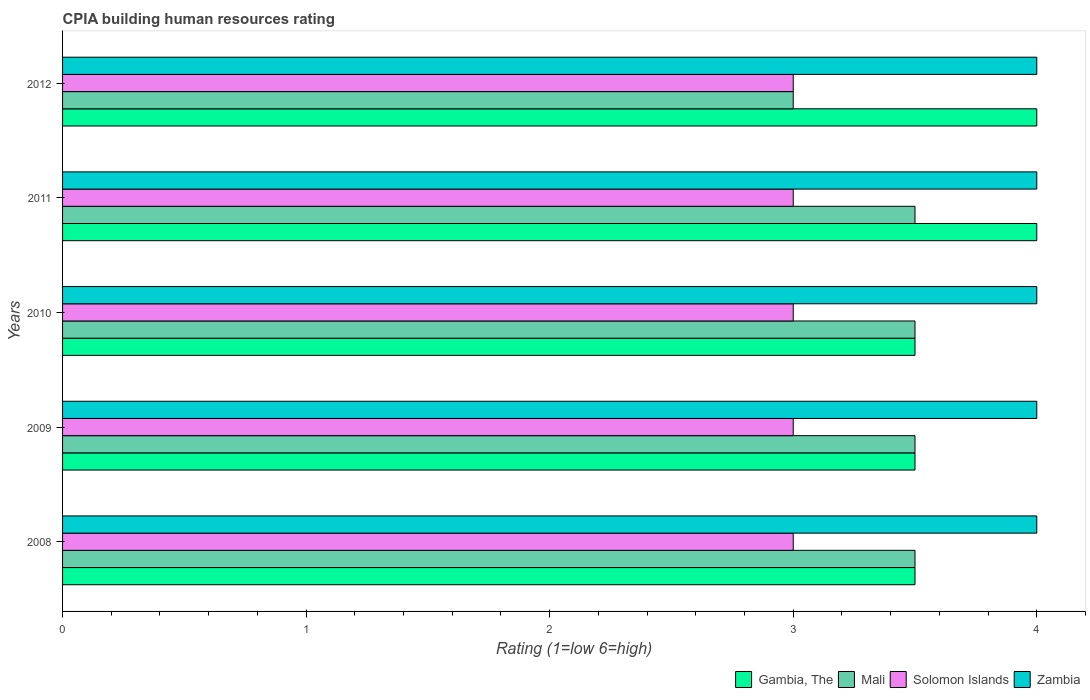How many different coloured bars are there?
Give a very brief answer. 4. How many groups of bars are there?
Provide a succinct answer. 5. Are the number of bars on each tick of the Y-axis equal?
Your response must be concise. Yes. How many bars are there on the 4th tick from the bottom?
Offer a terse response. 4. What is the label of the 3rd group of bars from the top?
Ensure brevity in your answer.  2010. In how many cases, is the number of bars for a given year not equal to the number of legend labels?
Offer a very short reply. 0. What is the CPIA rating in Mali in 2011?
Make the answer very short. 3.5. Across all years, what is the maximum CPIA rating in Gambia, The?
Offer a very short reply. 4. Across all years, what is the minimum CPIA rating in Mali?
Keep it short and to the point. 3. In which year was the CPIA rating in Zambia maximum?
Give a very brief answer. 2008. In which year was the CPIA rating in Zambia minimum?
Provide a short and direct response. 2008. What is the total CPIA rating in Mali in the graph?
Provide a succinct answer. 17. In the year 2008, what is the difference between the CPIA rating in Gambia, The and CPIA rating in Solomon Islands?
Your answer should be very brief. 0.5. In how many years, is the CPIA rating in Mali greater than 1.6 ?
Your response must be concise. 5. What is the ratio of the CPIA rating in Solomon Islands in 2010 to that in 2011?
Give a very brief answer. 1. Is the CPIA rating in Zambia in 2008 less than that in 2010?
Your answer should be very brief. No. What does the 1st bar from the top in 2009 represents?
Provide a short and direct response. Zambia. What does the 3rd bar from the bottom in 2009 represents?
Keep it short and to the point. Solomon Islands. Are all the bars in the graph horizontal?
Offer a very short reply. Yes. How many years are there in the graph?
Your answer should be very brief. 5. What is the difference between two consecutive major ticks on the X-axis?
Give a very brief answer. 1. Are the values on the major ticks of X-axis written in scientific E-notation?
Your response must be concise. No. Does the graph contain any zero values?
Keep it short and to the point. No. Does the graph contain grids?
Offer a terse response. No. Where does the legend appear in the graph?
Offer a terse response. Bottom right. How many legend labels are there?
Offer a terse response. 4. How are the legend labels stacked?
Your response must be concise. Horizontal. What is the title of the graph?
Your response must be concise. CPIA building human resources rating. What is the label or title of the Y-axis?
Keep it short and to the point. Years. What is the Rating (1=low 6=high) of Mali in 2008?
Provide a succinct answer. 3.5. What is the Rating (1=low 6=high) in Solomon Islands in 2008?
Make the answer very short. 3. What is the Rating (1=low 6=high) of Zambia in 2008?
Your response must be concise. 4. What is the Rating (1=low 6=high) in Mali in 2009?
Give a very brief answer. 3.5. What is the Rating (1=low 6=high) in Zambia in 2009?
Provide a succinct answer. 4. What is the Rating (1=low 6=high) of Gambia, The in 2010?
Your answer should be very brief. 3.5. What is the Rating (1=low 6=high) in Solomon Islands in 2010?
Provide a short and direct response. 3. What is the Rating (1=low 6=high) in Gambia, The in 2011?
Offer a terse response. 4. What is the Rating (1=low 6=high) of Mali in 2011?
Offer a terse response. 3.5. What is the Rating (1=low 6=high) of Gambia, The in 2012?
Your answer should be very brief. 4. What is the Rating (1=low 6=high) in Solomon Islands in 2012?
Your answer should be compact. 3. What is the Rating (1=low 6=high) of Zambia in 2012?
Your response must be concise. 4. Across all years, what is the maximum Rating (1=low 6=high) in Mali?
Offer a terse response. 3.5. Across all years, what is the maximum Rating (1=low 6=high) of Solomon Islands?
Your answer should be compact. 3. Across all years, what is the minimum Rating (1=low 6=high) of Gambia, The?
Offer a very short reply. 3.5. Across all years, what is the minimum Rating (1=low 6=high) in Mali?
Your answer should be compact. 3. Across all years, what is the minimum Rating (1=low 6=high) in Solomon Islands?
Give a very brief answer. 3. What is the total Rating (1=low 6=high) in Gambia, The in the graph?
Ensure brevity in your answer.  18.5. What is the total Rating (1=low 6=high) of Solomon Islands in the graph?
Your response must be concise. 15. What is the difference between the Rating (1=low 6=high) of Mali in 2008 and that in 2009?
Offer a very short reply. 0. What is the difference between the Rating (1=low 6=high) of Solomon Islands in 2008 and that in 2009?
Your answer should be compact. 0. What is the difference between the Rating (1=low 6=high) in Zambia in 2008 and that in 2009?
Offer a terse response. 0. What is the difference between the Rating (1=low 6=high) of Solomon Islands in 2008 and that in 2010?
Provide a short and direct response. 0. What is the difference between the Rating (1=low 6=high) in Zambia in 2008 and that in 2010?
Offer a very short reply. 0. What is the difference between the Rating (1=low 6=high) in Gambia, The in 2008 and that in 2011?
Ensure brevity in your answer.  -0.5. What is the difference between the Rating (1=low 6=high) in Mali in 2008 and that in 2011?
Offer a terse response. 0. What is the difference between the Rating (1=low 6=high) of Solomon Islands in 2008 and that in 2011?
Offer a very short reply. 0. What is the difference between the Rating (1=low 6=high) in Zambia in 2008 and that in 2011?
Offer a very short reply. 0. What is the difference between the Rating (1=low 6=high) in Gambia, The in 2008 and that in 2012?
Provide a succinct answer. -0.5. What is the difference between the Rating (1=low 6=high) in Mali in 2008 and that in 2012?
Ensure brevity in your answer.  0.5. What is the difference between the Rating (1=low 6=high) of Gambia, The in 2009 and that in 2010?
Offer a terse response. 0. What is the difference between the Rating (1=low 6=high) in Solomon Islands in 2009 and that in 2010?
Ensure brevity in your answer.  0. What is the difference between the Rating (1=low 6=high) in Zambia in 2009 and that in 2010?
Your answer should be compact. 0. What is the difference between the Rating (1=low 6=high) in Solomon Islands in 2009 and that in 2011?
Ensure brevity in your answer.  0. What is the difference between the Rating (1=low 6=high) of Solomon Islands in 2009 and that in 2012?
Ensure brevity in your answer.  0. What is the difference between the Rating (1=low 6=high) in Zambia in 2009 and that in 2012?
Offer a terse response. 0. What is the difference between the Rating (1=low 6=high) in Gambia, The in 2010 and that in 2011?
Your answer should be compact. -0.5. What is the difference between the Rating (1=low 6=high) of Mali in 2010 and that in 2011?
Your answer should be compact. 0. What is the difference between the Rating (1=low 6=high) in Solomon Islands in 2010 and that in 2011?
Offer a terse response. 0. What is the difference between the Rating (1=low 6=high) in Zambia in 2010 and that in 2011?
Offer a terse response. 0. What is the difference between the Rating (1=low 6=high) of Gambia, The in 2010 and that in 2012?
Provide a short and direct response. -0.5. What is the difference between the Rating (1=low 6=high) of Mali in 2010 and that in 2012?
Your response must be concise. 0.5. What is the difference between the Rating (1=low 6=high) of Solomon Islands in 2010 and that in 2012?
Offer a very short reply. 0. What is the difference between the Rating (1=low 6=high) in Zambia in 2010 and that in 2012?
Provide a succinct answer. 0. What is the difference between the Rating (1=low 6=high) of Gambia, The in 2011 and that in 2012?
Your answer should be very brief. 0. What is the difference between the Rating (1=low 6=high) in Solomon Islands in 2011 and that in 2012?
Provide a short and direct response. 0. What is the difference between the Rating (1=low 6=high) in Gambia, The in 2008 and the Rating (1=low 6=high) in Zambia in 2009?
Your response must be concise. -0.5. What is the difference between the Rating (1=low 6=high) of Mali in 2008 and the Rating (1=low 6=high) of Solomon Islands in 2009?
Your answer should be compact. 0.5. What is the difference between the Rating (1=low 6=high) in Gambia, The in 2008 and the Rating (1=low 6=high) in Solomon Islands in 2010?
Provide a short and direct response. 0.5. What is the difference between the Rating (1=low 6=high) of Gambia, The in 2008 and the Rating (1=low 6=high) of Zambia in 2010?
Ensure brevity in your answer.  -0.5. What is the difference between the Rating (1=low 6=high) of Mali in 2008 and the Rating (1=low 6=high) of Zambia in 2010?
Keep it short and to the point. -0.5. What is the difference between the Rating (1=low 6=high) in Solomon Islands in 2008 and the Rating (1=low 6=high) in Zambia in 2010?
Offer a terse response. -1. What is the difference between the Rating (1=low 6=high) in Gambia, The in 2008 and the Rating (1=low 6=high) in Solomon Islands in 2011?
Ensure brevity in your answer.  0.5. What is the difference between the Rating (1=low 6=high) in Gambia, The in 2008 and the Rating (1=low 6=high) in Zambia in 2011?
Ensure brevity in your answer.  -0.5. What is the difference between the Rating (1=low 6=high) in Mali in 2008 and the Rating (1=low 6=high) in Solomon Islands in 2011?
Your answer should be very brief. 0.5. What is the difference between the Rating (1=low 6=high) of Mali in 2008 and the Rating (1=low 6=high) of Zambia in 2011?
Provide a short and direct response. -0.5. What is the difference between the Rating (1=low 6=high) in Gambia, The in 2008 and the Rating (1=low 6=high) in Mali in 2012?
Offer a terse response. 0.5. What is the difference between the Rating (1=low 6=high) in Gambia, The in 2008 and the Rating (1=low 6=high) in Solomon Islands in 2012?
Give a very brief answer. 0.5. What is the difference between the Rating (1=low 6=high) of Gambia, The in 2008 and the Rating (1=low 6=high) of Zambia in 2012?
Make the answer very short. -0.5. What is the difference between the Rating (1=low 6=high) of Mali in 2008 and the Rating (1=low 6=high) of Zambia in 2012?
Give a very brief answer. -0.5. What is the difference between the Rating (1=low 6=high) of Gambia, The in 2009 and the Rating (1=low 6=high) of Solomon Islands in 2010?
Offer a terse response. 0.5. What is the difference between the Rating (1=low 6=high) in Gambia, The in 2009 and the Rating (1=low 6=high) in Zambia in 2010?
Keep it short and to the point. -0.5. What is the difference between the Rating (1=low 6=high) of Mali in 2009 and the Rating (1=low 6=high) of Solomon Islands in 2010?
Provide a succinct answer. 0.5. What is the difference between the Rating (1=low 6=high) of Mali in 2009 and the Rating (1=low 6=high) of Zambia in 2010?
Provide a succinct answer. -0.5. What is the difference between the Rating (1=low 6=high) in Solomon Islands in 2009 and the Rating (1=low 6=high) in Zambia in 2010?
Give a very brief answer. -1. What is the difference between the Rating (1=low 6=high) in Gambia, The in 2009 and the Rating (1=low 6=high) in Solomon Islands in 2011?
Offer a terse response. 0.5. What is the difference between the Rating (1=low 6=high) in Mali in 2009 and the Rating (1=low 6=high) in Solomon Islands in 2011?
Provide a short and direct response. 0.5. What is the difference between the Rating (1=low 6=high) in Mali in 2009 and the Rating (1=low 6=high) in Zambia in 2011?
Make the answer very short. -0.5. What is the difference between the Rating (1=low 6=high) in Solomon Islands in 2009 and the Rating (1=low 6=high) in Zambia in 2011?
Ensure brevity in your answer.  -1. What is the difference between the Rating (1=low 6=high) in Gambia, The in 2009 and the Rating (1=low 6=high) in Zambia in 2012?
Provide a succinct answer. -0.5. What is the difference between the Rating (1=low 6=high) of Mali in 2009 and the Rating (1=low 6=high) of Solomon Islands in 2012?
Provide a short and direct response. 0.5. What is the difference between the Rating (1=low 6=high) in Solomon Islands in 2009 and the Rating (1=low 6=high) in Zambia in 2012?
Your response must be concise. -1. What is the difference between the Rating (1=low 6=high) of Gambia, The in 2010 and the Rating (1=low 6=high) of Mali in 2011?
Make the answer very short. 0. What is the difference between the Rating (1=low 6=high) of Mali in 2010 and the Rating (1=low 6=high) of Solomon Islands in 2011?
Keep it short and to the point. 0.5. What is the difference between the Rating (1=low 6=high) in Mali in 2010 and the Rating (1=low 6=high) in Zambia in 2011?
Give a very brief answer. -0.5. What is the difference between the Rating (1=low 6=high) in Gambia, The in 2010 and the Rating (1=low 6=high) in Mali in 2012?
Make the answer very short. 0.5. What is the difference between the Rating (1=low 6=high) in Solomon Islands in 2010 and the Rating (1=low 6=high) in Zambia in 2012?
Keep it short and to the point. -1. What is the difference between the Rating (1=low 6=high) of Gambia, The in 2011 and the Rating (1=low 6=high) of Mali in 2012?
Keep it short and to the point. 1. What is the average Rating (1=low 6=high) of Mali per year?
Your response must be concise. 3.4. In the year 2008, what is the difference between the Rating (1=low 6=high) in Gambia, The and Rating (1=low 6=high) in Solomon Islands?
Make the answer very short. 0.5. In the year 2008, what is the difference between the Rating (1=low 6=high) in Gambia, The and Rating (1=low 6=high) in Zambia?
Ensure brevity in your answer.  -0.5. In the year 2008, what is the difference between the Rating (1=low 6=high) of Mali and Rating (1=low 6=high) of Zambia?
Your answer should be very brief. -0.5. In the year 2008, what is the difference between the Rating (1=low 6=high) in Solomon Islands and Rating (1=low 6=high) in Zambia?
Ensure brevity in your answer.  -1. In the year 2009, what is the difference between the Rating (1=low 6=high) of Gambia, The and Rating (1=low 6=high) of Solomon Islands?
Ensure brevity in your answer.  0.5. In the year 2009, what is the difference between the Rating (1=low 6=high) in Mali and Rating (1=low 6=high) in Solomon Islands?
Keep it short and to the point. 0.5. In the year 2009, what is the difference between the Rating (1=low 6=high) in Solomon Islands and Rating (1=low 6=high) in Zambia?
Make the answer very short. -1. In the year 2010, what is the difference between the Rating (1=low 6=high) in Gambia, The and Rating (1=low 6=high) in Solomon Islands?
Provide a succinct answer. 0.5. In the year 2010, what is the difference between the Rating (1=low 6=high) of Gambia, The and Rating (1=low 6=high) of Zambia?
Keep it short and to the point. -0.5. In the year 2011, what is the difference between the Rating (1=low 6=high) of Gambia, The and Rating (1=low 6=high) of Mali?
Provide a short and direct response. 0.5. In the year 2011, what is the difference between the Rating (1=low 6=high) in Gambia, The and Rating (1=low 6=high) in Zambia?
Give a very brief answer. 0. In the year 2011, what is the difference between the Rating (1=low 6=high) in Mali and Rating (1=low 6=high) in Zambia?
Offer a terse response. -0.5. In the year 2012, what is the difference between the Rating (1=low 6=high) of Gambia, The and Rating (1=low 6=high) of Solomon Islands?
Provide a succinct answer. 1. In the year 2012, what is the difference between the Rating (1=low 6=high) in Gambia, The and Rating (1=low 6=high) in Zambia?
Keep it short and to the point. 0. In the year 2012, what is the difference between the Rating (1=low 6=high) in Mali and Rating (1=low 6=high) in Solomon Islands?
Give a very brief answer. 0. In the year 2012, what is the difference between the Rating (1=low 6=high) of Mali and Rating (1=low 6=high) of Zambia?
Provide a succinct answer. -1. In the year 2012, what is the difference between the Rating (1=low 6=high) in Solomon Islands and Rating (1=low 6=high) in Zambia?
Ensure brevity in your answer.  -1. What is the ratio of the Rating (1=low 6=high) of Gambia, The in 2008 to that in 2009?
Your response must be concise. 1. What is the ratio of the Rating (1=low 6=high) in Solomon Islands in 2008 to that in 2009?
Keep it short and to the point. 1. What is the ratio of the Rating (1=low 6=high) of Zambia in 2008 to that in 2009?
Keep it short and to the point. 1. What is the ratio of the Rating (1=low 6=high) of Mali in 2008 to that in 2010?
Provide a short and direct response. 1. What is the ratio of the Rating (1=low 6=high) in Gambia, The in 2008 to that in 2011?
Your answer should be compact. 0.88. What is the ratio of the Rating (1=low 6=high) in Zambia in 2008 to that in 2011?
Offer a terse response. 1. What is the ratio of the Rating (1=low 6=high) in Gambia, The in 2008 to that in 2012?
Provide a succinct answer. 0.88. What is the ratio of the Rating (1=low 6=high) of Mali in 2008 to that in 2012?
Offer a terse response. 1.17. What is the ratio of the Rating (1=low 6=high) in Solomon Islands in 2008 to that in 2012?
Your answer should be very brief. 1. What is the ratio of the Rating (1=low 6=high) of Zambia in 2008 to that in 2012?
Ensure brevity in your answer.  1. What is the ratio of the Rating (1=low 6=high) of Mali in 2009 to that in 2010?
Keep it short and to the point. 1. What is the ratio of the Rating (1=low 6=high) of Solomon Islands in 2009 to that in 2010?
Provide a succinct answer. 1. What is the ratio of the Rating (1=low 6=high) in Zambia in 2009 to that in 2010?
Offer a terse response. 1. What is the ratio of the Rating (1=low 6=high) of Solomon Islands in 2009 to that in 2011?
Your answer should be compact. 1. What is the ratio of the Rating (1=low 6=high) of Zambia in 2009 to that in 2011?
Your answer should be very brief. 1. What is the ratio of the Rating (1=low 6=high) in Mali in 2009 to that in 2012?
Offer a very short reply. 1.17. What is the ratio of the Rating (1=low 6=high) of Gambia, The in 2010 to that in 2012?
Your answer should be very brief. 0.88. What is the ratio of the Rating (1=low 6=high) of Mali in 2010 to that in 2012?
Your answer should be compact. 1.17. What is the ratio of the Rating (1=low 6=high) in Solomon Islands in 2010 to that in 2012?
Your answer should be compact. 1. What is the ratio of the Rating (1=low 6=high) in Zambia in 2010 to that in 2012?
Offer a very short reply. 1. What is the ratio of the Rating (1=low 6=high) in Solomon Islands in 2011 to that in 2012?
Make the answer very short. 1. What is the ratio of the Rating (1=low 6=high) in Zambia in 2011 to that in 2012?
Your answer should be very brief. 1. What is the difference between the highest and the second highest Rating (1=low 6=high) of Gambia, The?
Offer a very short reply. 0. What is the difference between the highest and the second highest Rating (1=low 6=high) of Solomon Islands?
Your response must be concise. 0. What is the difference between the highest and the lowest Rating (1=low 6=high) in Solomon Islands?
Your response must be concise. 0. 